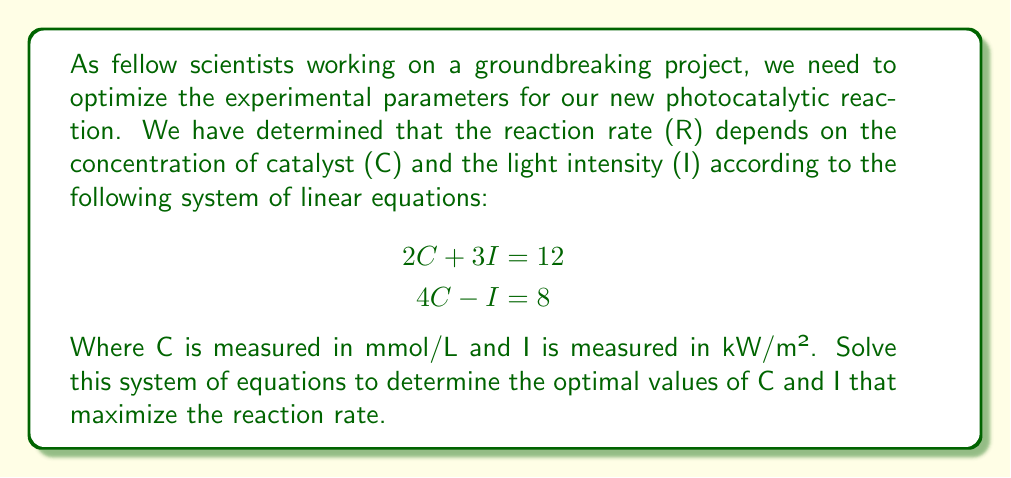Give your solution to this math problem. To solve this system of linear equations, we'll use the substitution method:

1) From the second equation, express I in terms of C:
   $$4C - I = 8$$
   $$-I = 8 - 4C$$
   $$I = 4C - 8$$ (1)

2) Substitute this expression for I into the first equation:
   $$2C + 3(4C - 8) = 12$$

3) Simplify:
   $$2C + 12C - 24 = 12$$
   $$14C - 24 = 12$$
   $$14C = 36$$

4) Solve for C:
   $$C = \frac{36}{14} = \frac{18}{7} \approx 2.57$$ mmol/L

5) Now substitute this value of C back into equation (1) to find I:
   $$I = 4(\frac{18}{7}) - 8$$
   $$I = \frac{72}{7} - 8$$
   $$I = \frac{72}{7} - \frac{56}{7}$$
   $$I = \frac{16}{7} \approx 2.29$$ kW/m²

6) Verify the solution by plugging these values back into both original equations:
   
   Equation 1: $2(2.57) + 3(2.29) \approx 12$
   Equation 2: $4(2.57) - 2.29 \approx 8$

   Both equations are satisfied, confirming our solution.
Answer: The optimal experimental parameters are:
Catalyst concentration (C) = $\frac{18}{7} \approx 2.57$ mmol/L
Light intensity (I) = $\frac{16}{7} \approx 2.29$ kW/m² 